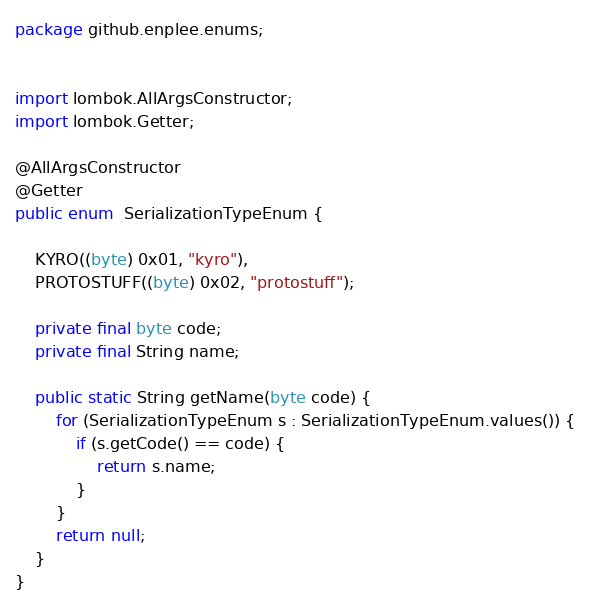<code> <loc_0><loc_0><loc_500><loc_500><_Java_>package github.enplee.enums;


import lombok.AllArgsConstructor;
import lombok.Getter;

@AllArgsConstructor
@Getter
public enum  SerializationTypeEnum {

    KYRO((byte) 0x01, "kyro"),
    PROTOSTUFF((byte) 0x02, "protostuff");

    private final byte code;
    private final String name;

    public static String getName(byte code) {
        for (SerializationTypeEnum s : SerializationTypeEnum.values()) {
            if (s.getCode() == code) {
                return s.name;
            }
        }
        return null;
    }
}
</code> 